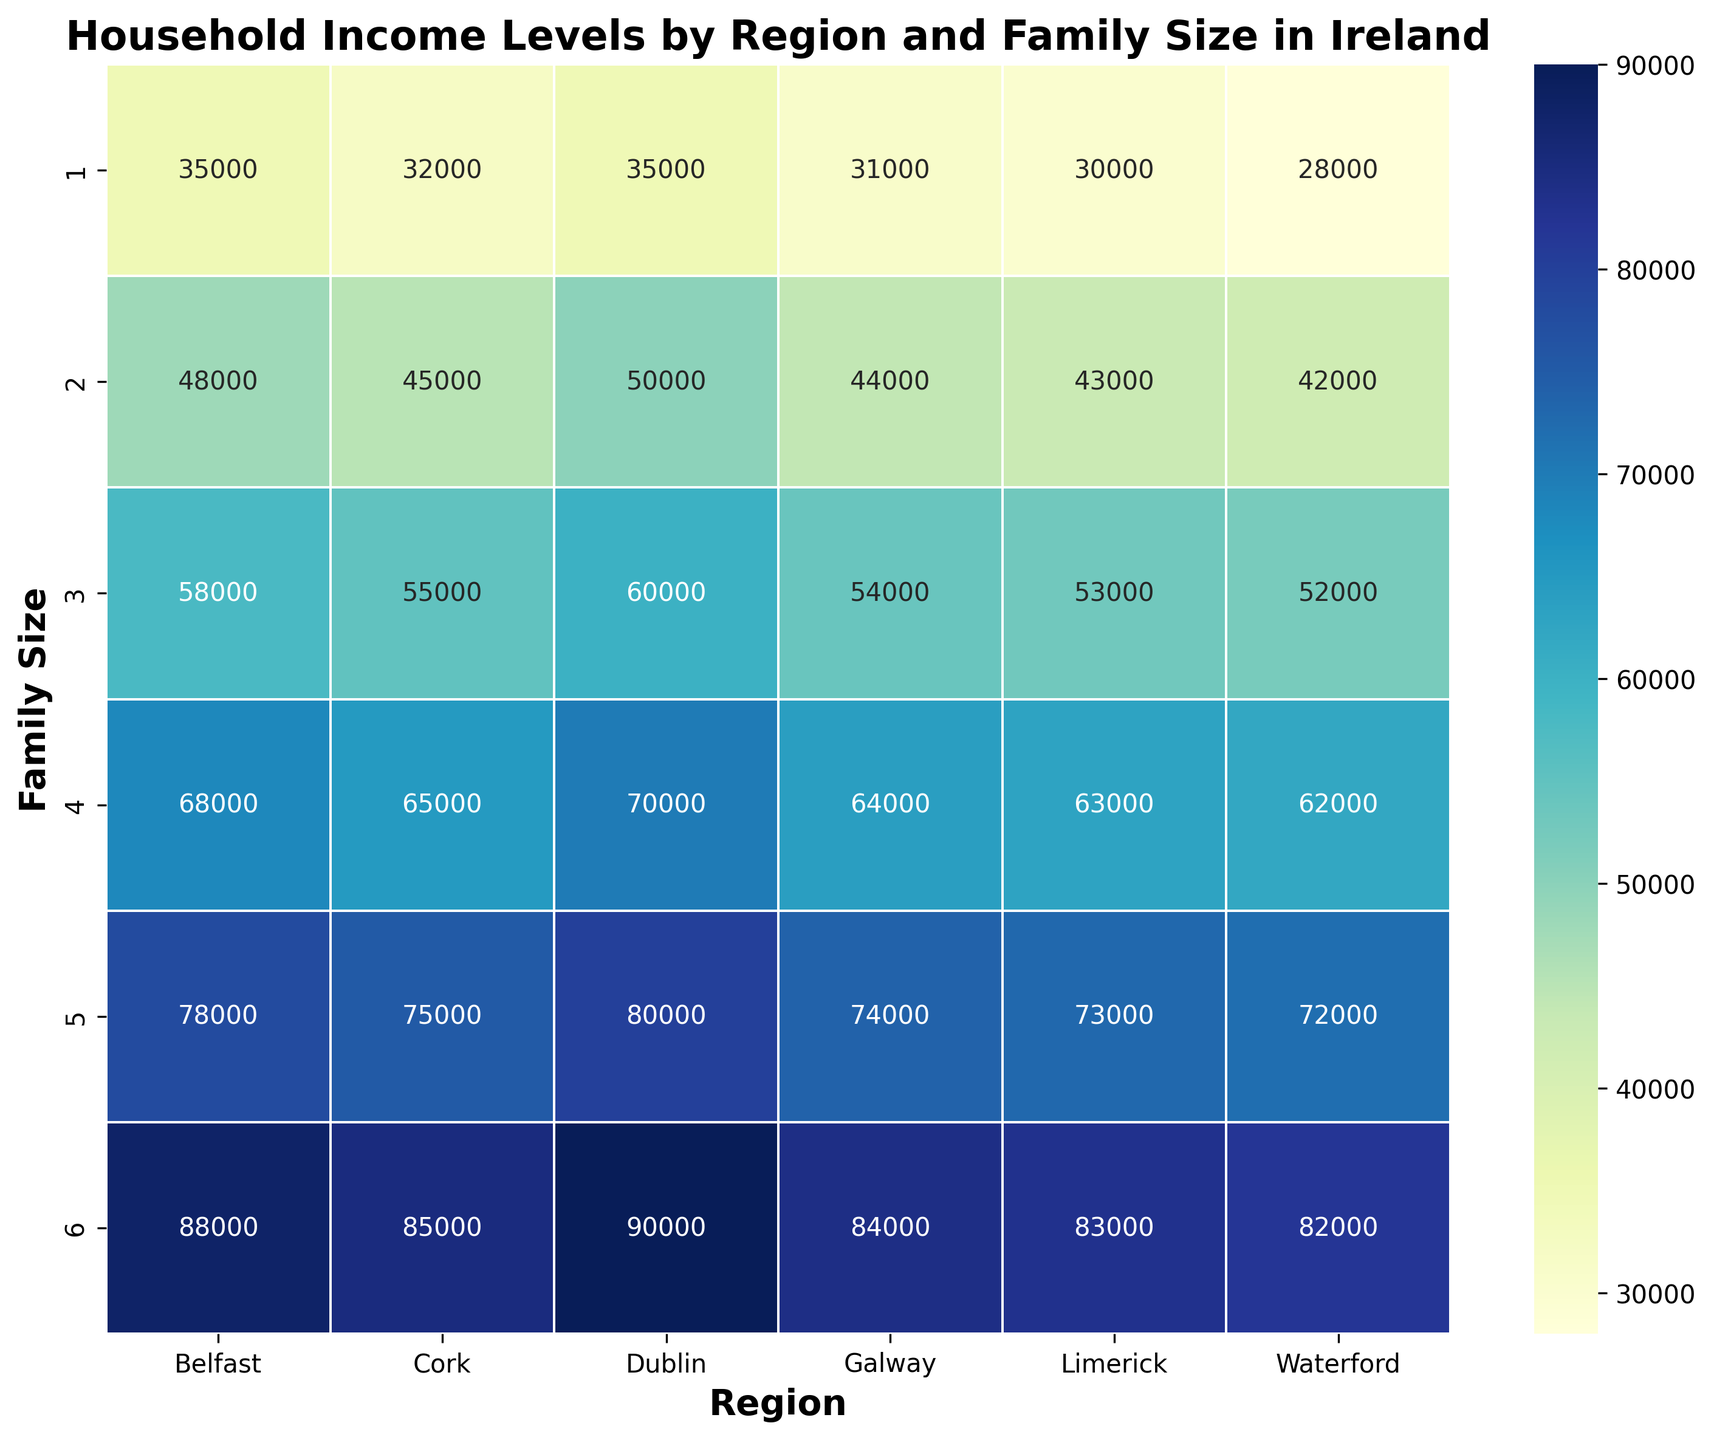What's the average household income for a family size of 4 across all regions? First, identify the household incomes for a family size of 4 in each region: Dublin (70,000), Cork (65,000), Limerick (63,000), Galway (64,000), Waterford (62,000), and Belfast (68,000). Sum them: 70,000 + 65,000 + 63,000 + 64,000 + 62,000 + 68,000 = 392,000. Divide by 6 (the number of regions) for the average: 392,000 / 6 = 65,333.33.
Answer: 65,333.33 Which region has the highest household income for a family size of 3? Compare the household incomes for a family size of 3 across all regions: Dublin (60,000), Cork (55,000), Limerick (53,000), Galway (54,000), Waterford (52,000), and Belfast (58,000). The highest value is in Dublin.
Answer: Dublin Is the household income in Dublin greater than in Cork for all family sizes? Compare household incomes for each family size in Dublin and Cork: 1 (35,000 vs. 32,000), 2 (50,000 vs. 45,000), 3 (60,000 vs. 55,000), 4 (70,000 vs. 65,000), 5 (80,000 vs. 75,000), 6 (90,000 vs. 85,000). Dublin's incomes are higher across all family sizes.
Answer: Yes What is the visual pattern of household income between family sizes in Dublin compared to Limerick? Look at the color gradient for both regions. Lower family sizes in both Dublin and Limerick have lighter colors and progressively get darker as family size increases, indicating increasing household income. Dublin has consistently darker shades (higher income) compared to Limerick.
Answer: Dublin has uniformly higher incomes and darker shades Which region has the most visually consistent average household income across all family sizes? Visually inspect the color consistency for each region across family sizes. Belfast's color shades are the most consistently medium, suggesting a relatively even household income.
Answer: Belfast 